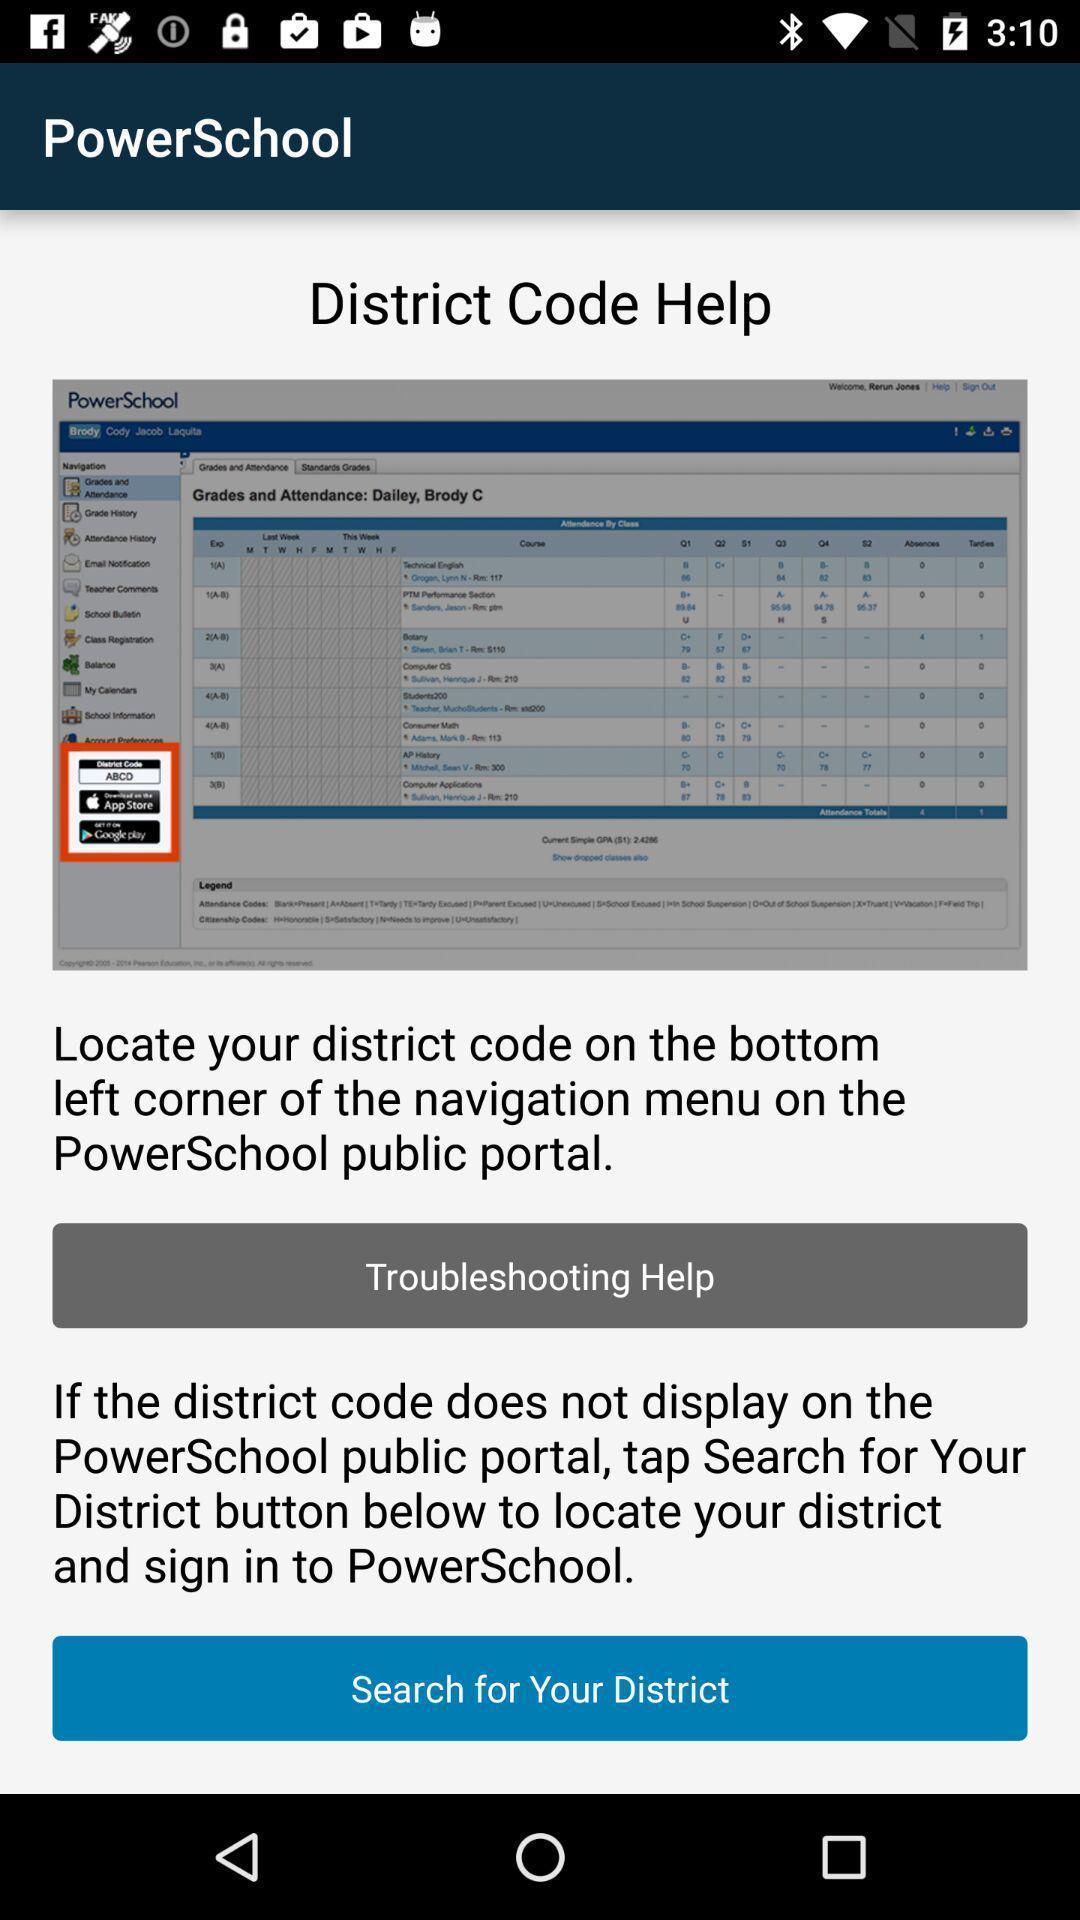Explain what's happening in this screen capture. Page showing help for searching your district code. 